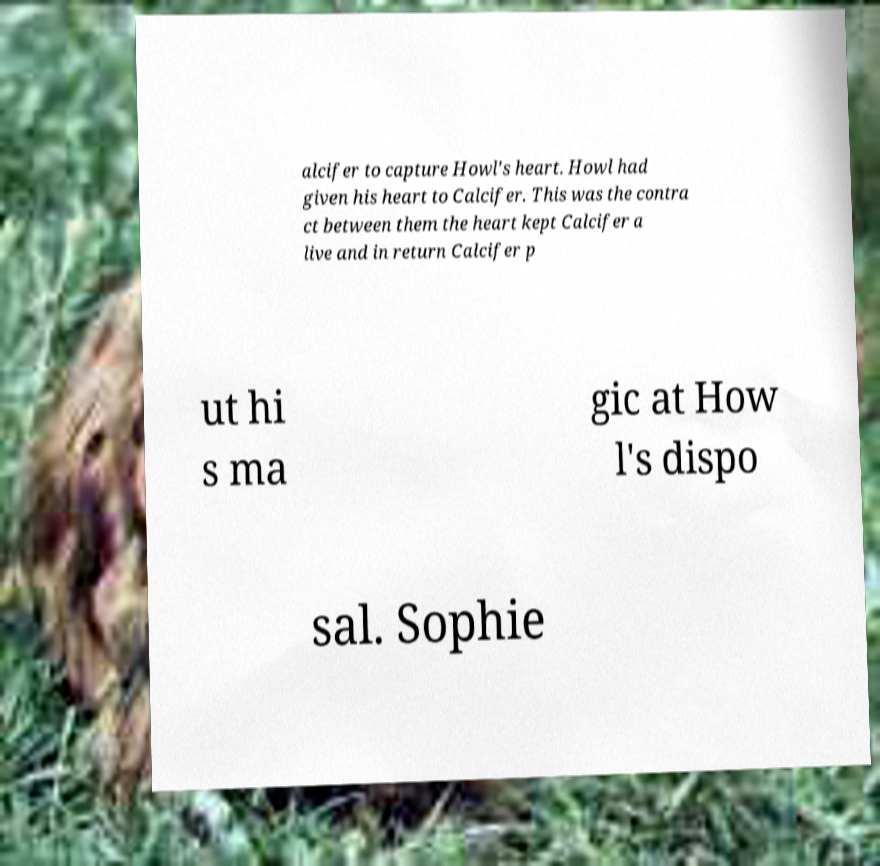Please read and relay the text visible in this image. What does it say? alcifer to capture Howl's heart. Howl had given his heart to Calcifer. This was the contra ct between them the heart kept Calcifer a live and in return Calcifer p ut hi s ma gic at How l's dispo sal. Sophie 